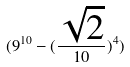<formula> <loc_0><loc_0><loc_500><loc_500>( 9 ^ { 1 0 } - ( \frac { \sqrt { 2 } } { 1 0 } ) ^ { 4 } )</formula> 